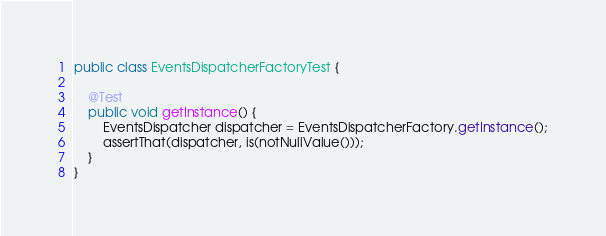Convert code to text. <code><loc_0><loc_0><loc_500><loc_500><_Java_>
public class EventsDispatcherFactoryTest {

    @Test
    public void getInstance() {
        EventsDispatcher dispatcher = EventsDispatcherFactory.getInstance();
        assertThat(dispatcher, is(notNullValue()));
    }
}
</code> 